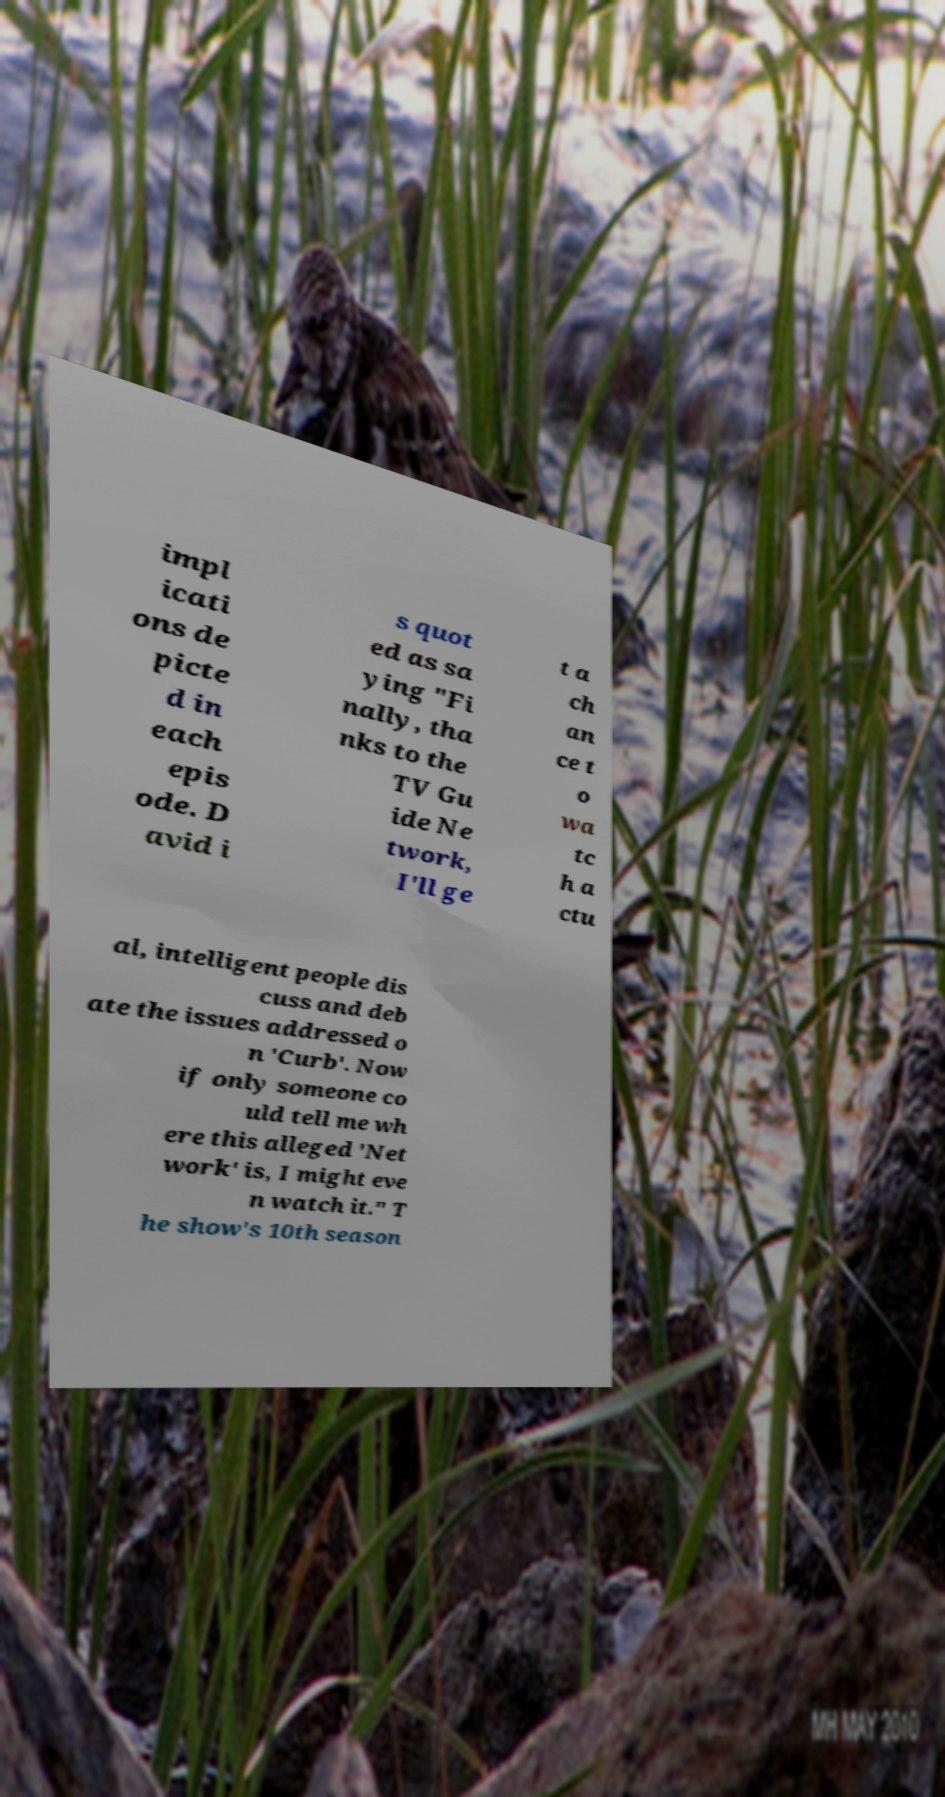Could you assist in decoding the text presented in this image and type it out clearly? impl icati ons de picte d in each epis ode. D avid i s quot ed as sa ying "Fi nally, tha nks to the TV Gu ide Ne twork, I'll ge t a ch an ce t o wa tc h a ctu al, intelligent people dis cuss and deb ate the issues addressed o n 'Curb'. Now if only someone co uld tell me wh ere this alleged 'Net work' is, I might eve n watch it." T he show's 10th season 